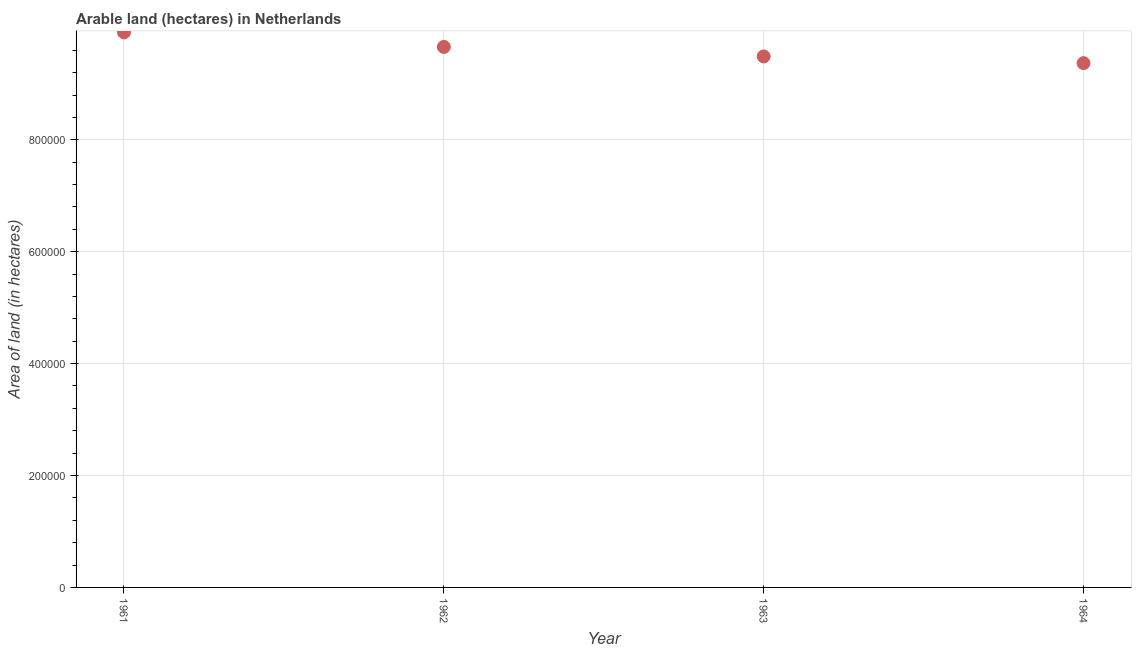What is the area of land in 1961?
Offer a very short reply. 9.92e+05. Across all years, what is the maximum area of land?
Offer a very short reply. 9.92e+05. Across all years, what is the minimum area of land?
Offer a very short reply. 9.37e+05. In which year was the area of land maximum?
Offer a terse response. 1961. In which year was the area of land minimum?
Keep it short and to the point. 1964. What is the sum of the area of land?
Your response must be concise. 3.84e+06. What is the difference between the area of land in 1961 and 1964?
Your answer should be very brief. 5.50e+04. What is the average area of land per year?
Your response must be concise. 9.61e+05. What is the median area of land?
Keep it short and to the point. 9.58e+05. What is the ratio of the area of land in 1961 to that in 1964?
Provide a succinct answer. 1.06. Is the area of land in 1961 less than that in 1962?
Make the answer very short. No. What is the difference between the highest and the second highest area of land?
Your answer should be compact. 2.60e+04. Is the sum of the area of land in 1961 and 1963 greater than the maximum area of land across all years?
Offer a terse response. Yes. What is the difference between the highest and the lowest area of land?
Your response must be concise. 5.50e+04. How many years are there in the graph?
Your response must be concise. 4. What is the difference between two consecutive major ticks on the Y-axis?
Ensure brevity in your answer.  2.00e+05. Are the values on the major ticks of Y-axis written in scientific E-notation?
Provide a short and direct response. No. What is the title of the graph?
Offer a very short reply. Arable land (hectares) in Netherlands. What is the label or title of the X-axis?
Your answer should be compact. Year. What is the label or title of the Y-axis?
Ensure brevity in your answer.  Area of land (in hectares). What is the Area of land (in hectares) in 1961?
Provide a succinct answer. 9.92e+05. What is the Area of land (in hectares) in 1962?
Your answer should be very brief. 9.66e+05. What is the Area of land (in hectares) in 1963?
Give a very brief answer. 9.49e+05. What is the Area of land (in hectares) in 1964?
Give a very brief answer. 9.37e+05. What is the difference between the Area of land (in hectares) in 1961 and 1962?
Keep it short and to the point. 2.60e+04. What is the difference between the Area of land (in hectares) in 1961 and 1963?
Your response must be concise. 4.30e+04. What is the difference between the Area of land (in hectares) in 1961 and 1964?
Make the answer very short. 5.50e+04. What is the difference between the Area of land (in hectares) in 1962 and 1963?
Provide a succinct answer. 1.70e+04. What is the difference between the Area of land (in hectares) in 1962 and 1964?
Your answer should be compact. 2.90e+04. What is the difference between the Area of land (in hectares) in 1963 and 1964?
Provide a succinct answer. 1.20e+04. What is the ratio of the Area of land (in hectares) in 1961 to that in 1962?
Keep it short and to the point. 1.03. What is the ratio of the Area of land (in hectares) in 1961 to that in 1963?
Ensure brevity in your answer.  1.04. What is the ratio of the Area of land (in hectares) in 1961 to that in 1964?
Offer a terse response. 1.06. What is the ratio of the Area of land (in hectares) in 1962 to that in 1964?
Ensure brevity in your answer.  1.03. 